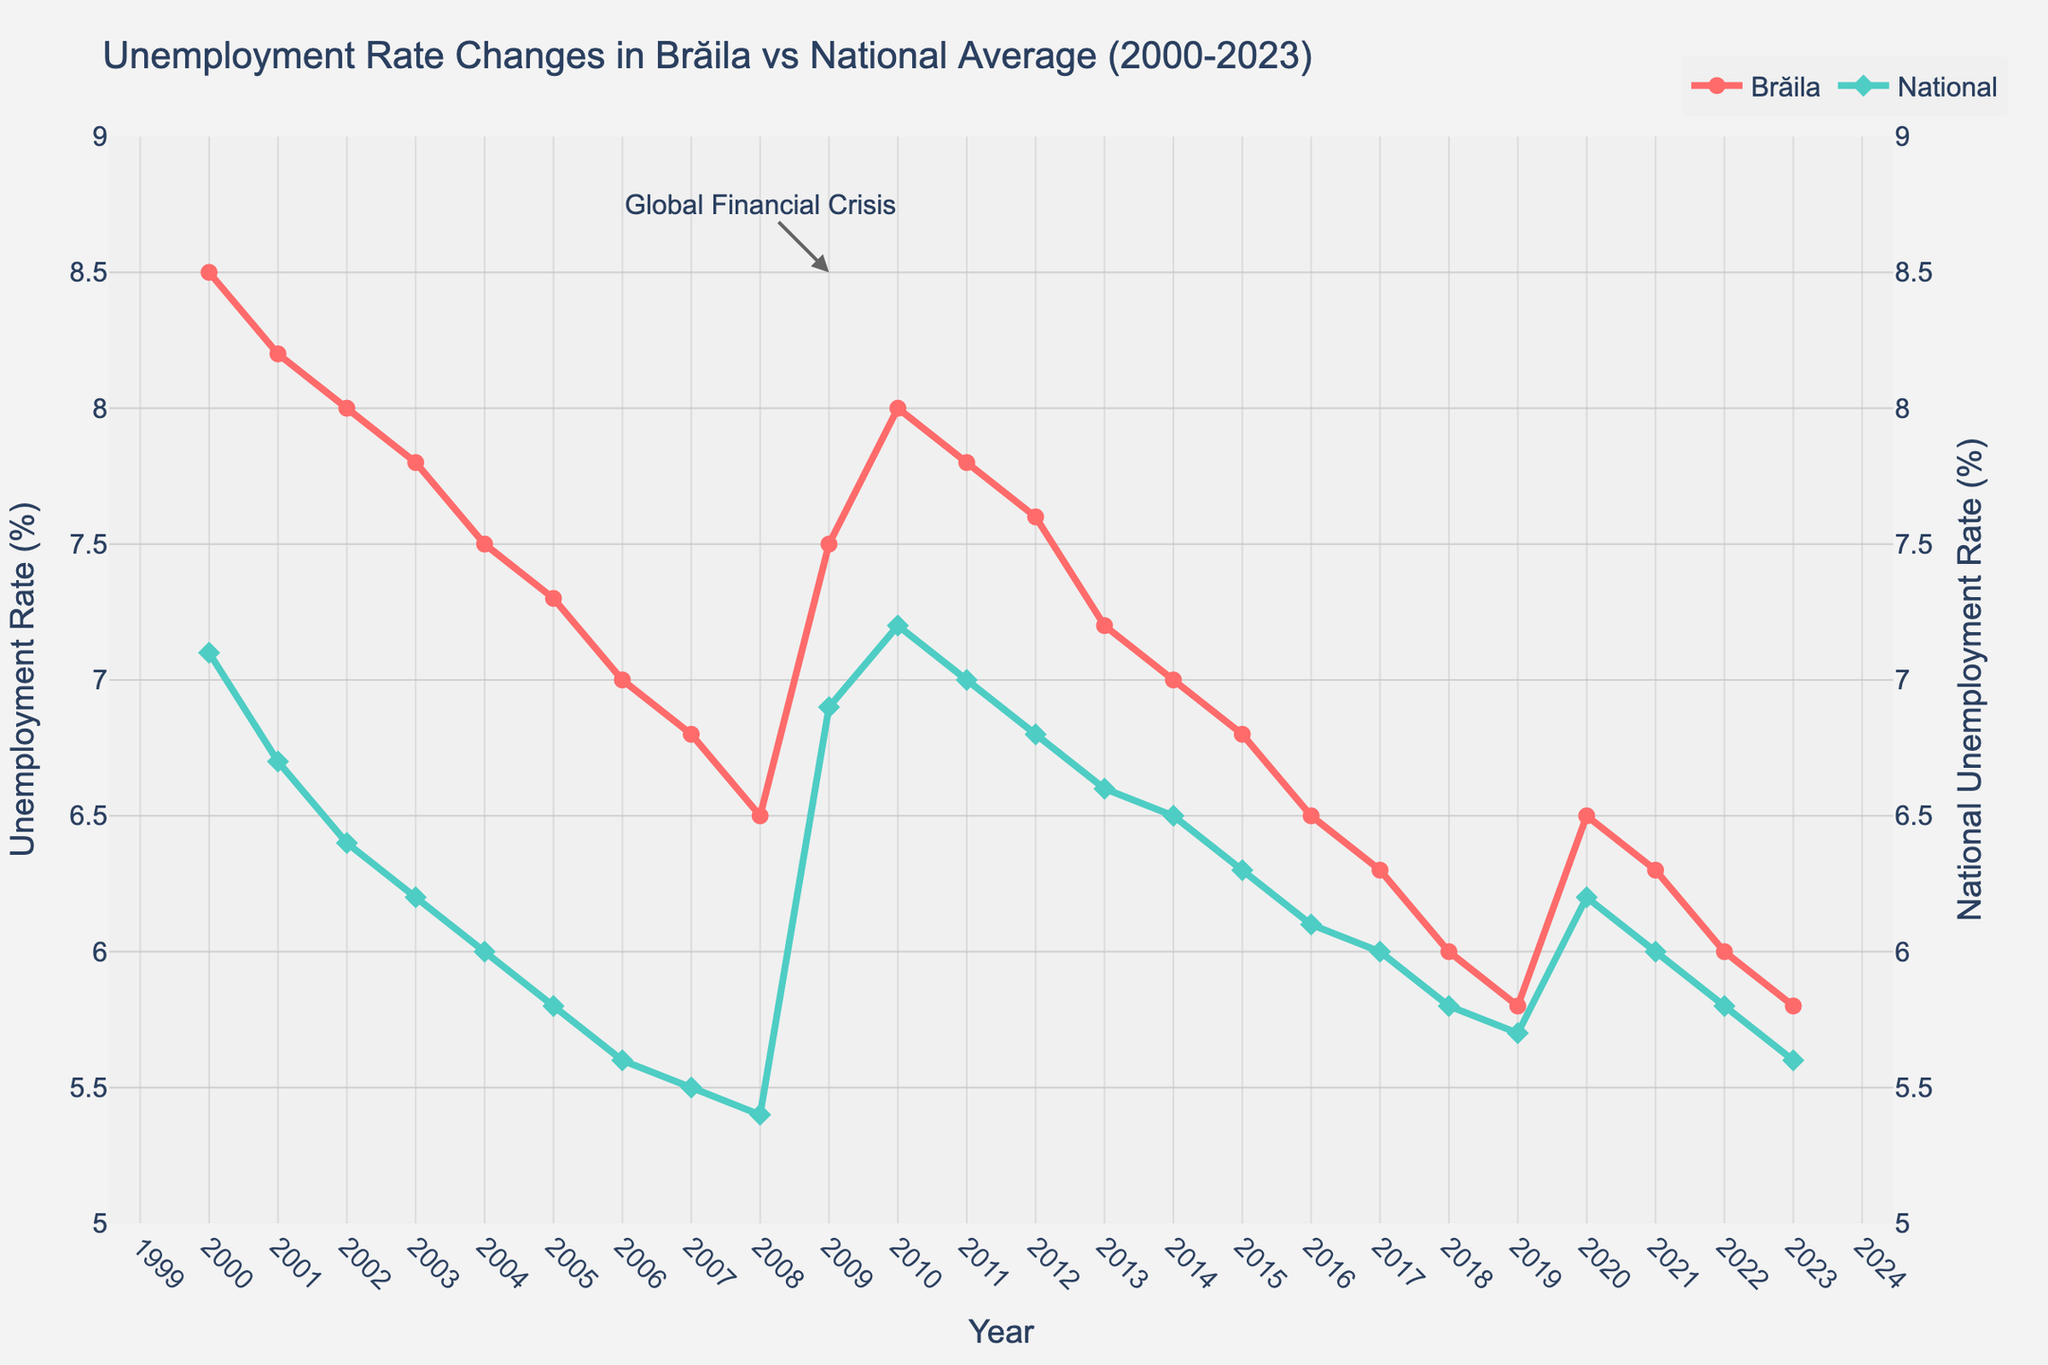What's the title of the plot? The title of the plot is written at the top of the figure. The title usually provides a brief description of the content of the plot.
Answer: Unemployment Rate Changes in Brăila vs National Average (2000-2023) What are the primary colors used for the lines representing Brăila and National unemployment rates? The lines representing Brăila and National unemployment rates are clearly differentiated using distinct colors.
Answer: Brăila: Red, National: Green How did the unemployment rate in Brăila change from 2000 to 2008? Looking at the Brăila Unemployment Rate line, you can see that it starts at 8.5% in 2000 and gradually decreases each year, reaching 6.5% in 2008.
Answer: It decreased from 8.5% to 6.5% What year did the Brăila unemployment rate reach its highest value, and what was that value? The line representing Brăila's unemployment rate has its peak at the highest point on the y-axis. By following the peak value back to the x-axis, you can determine the year.
Answer: 2000, 8.5% During the Global Financial Crisis of 2009, how did the unemployment rate change for Brăila and the national average? The annotation for the Global Financial Crisis is around 2009. Observing the change in the lines around this marker will show the changes in both Brăila and national rates. The Brăila rate jumps, as does the national rate.
Answer: Brăila: Increased by 1.0% (from 6.5% to 7.5%); National: Increased by 1.5% (from 5.4% to 6.9%) In which year did Brăila and the national unemployment rates show the smallest difference, and what was the difference? By closely examining the gap between the two lines year by year, you can identify the smallest difference visually. For the exact difference, compare the values for each year.
Answer: 2018, 0.2% Compare the patterns of change in the unemployment rates for Brăila and the national average from 2000 to 2023. To compare these patterns, follow each line from 2000 to 2023 and note their trends upwards and downwards. The Brăila line generally follows the national line but starts with higher values. Both lines show a decrease over the period, with peaks around the 2009 crisis.
Answer: Both decreased overall, with peaks in 2009 What's the overall trend for the unemployment rate in Brăila from 2000-2023? Observing the full span of the Brăila Unemployment Rate line from 2000 to 2023, we can see a general direction of movement. Starting high, dipping, peaking around 2009, and generally decreasing after.
Answer: Decreasing What was the unemployment rate for Brăila and the national average in the year 2023? Look at the end of both lines where they intersect the y-axis for the year 2023. This will provide the final values for that year.
Answer: Brăila: 5.8%, National: 5.6% Is there any year where the national unemployment rate was significantly higher than the Brăila unemployment rate? A significant difference would be a noticeable gap between the two lines, with the national line being above the Brăila line. Scan through the years to identify any such instance.
Answer: No, the Brăila rate was always higher or equal 